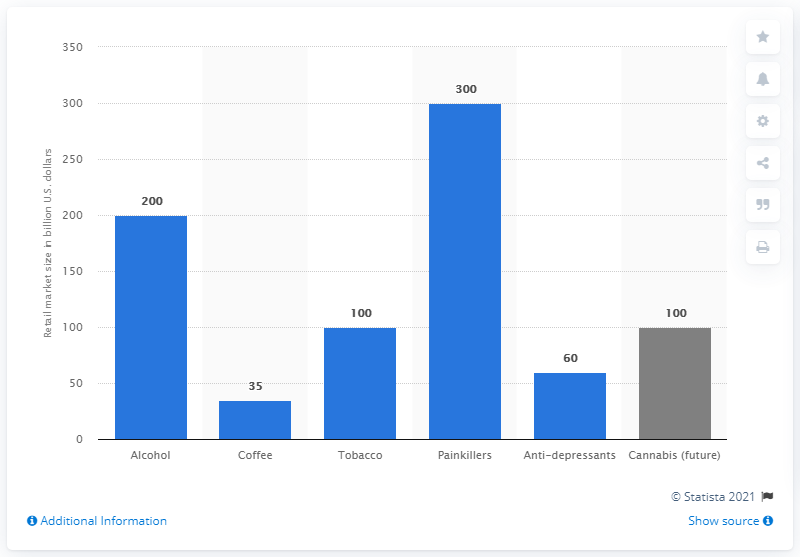Highlight a few significant elements in this photo. The retail market size of legal cannabis is estimated to be approximately 100. 